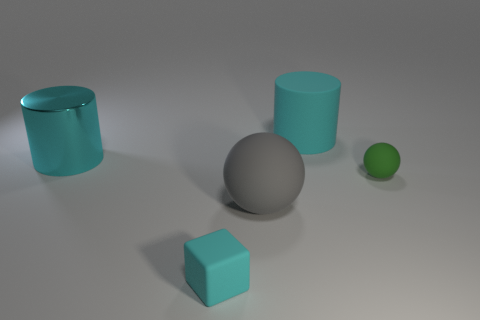There is a tiny block that is the same color as the shiny cylinder; what is it made of?
Keep it short and to the point. Rubber. How many gray matte cylinders are there?
Ensure brevity in your answer.  0. What shape is the tiny matte object that is behind the big ball?
Make the answer very short. Sphere. The matte thing that is behind the large cyan cylinder that is left of the tiny rubber thing that is in front of the gray object is what color?
Provide a succinct answer. Cyan. What is the shape of the large cyan thing that is made of the same material as the tiny green object?
Offer a terse response. Cylinder. Is the number of big cyan cylinders less than the number of yellow objects?
Keep it short and to the point. No. Is the gray ball made of the same material as the cyan cube?
Make the answer very short. Yes. How many other things are the same color as the shiny cylinder?
Your answer should be very brief. 2. Are there more gray rubber balls than big purple metal things?
Provide a succinct answer. Yes. Is the size of the rubber cube the same as the object left of the block?
Ensure brevity in your answer.  No. 